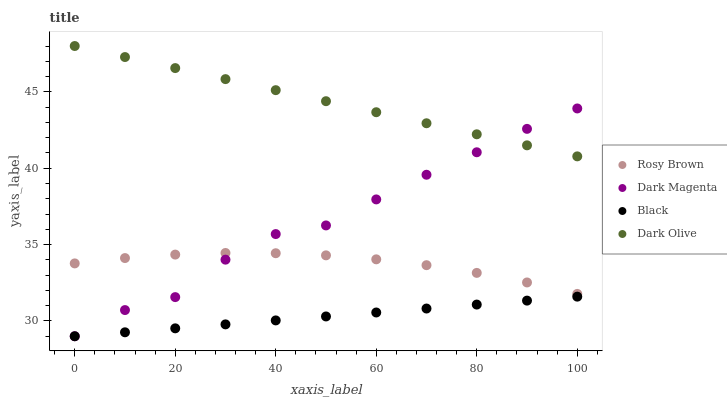Does Black have the minimum area under the curve?
Answer yes or no. Yes. Does Dark Olive have the maximum area under the curve?
Answer yes or no. Yes. Does Rosy Brown have the minimum area under the curve?
Answer yes or no. No. Does Rosy Brown have the maximum area under the curve?
Answer yes or no. No. Is Dark Olive the smoothest?
Answer yes or no. Yes. Is Dark Magenta the roughest?
Answer yes or no. Yes. Is Rosy Brown the smoothest?
Answer yes or no. No. Is Rosy Brown the roughest?
Answer yes or no. No. Does Black have the lowest value?
Answer yes or no. Yes. Does Rosy Brown have the lowest value?
Answer yes or no. No. Does Dark Olive have the highest value?
Answer yes or no. Yes. Does Rosy Brown have the highest value?
Answer yes or no. No. Is Black less than Dark Olive?
Answer yes or no. Yes. Is Rosy Brown greater than Black?
Answer yes or no. Yes. Does Dark Magenta intersect Dark Olive?
Answer yes or no. Yes. Is Dark Magenta less than Dark Olive?
Answer yes or no. No. Is Dark Magenta greater than Dark Olive?
Answer yes or no. No. Does Black intersect Dark Olive?
Answer yes or no. No. 